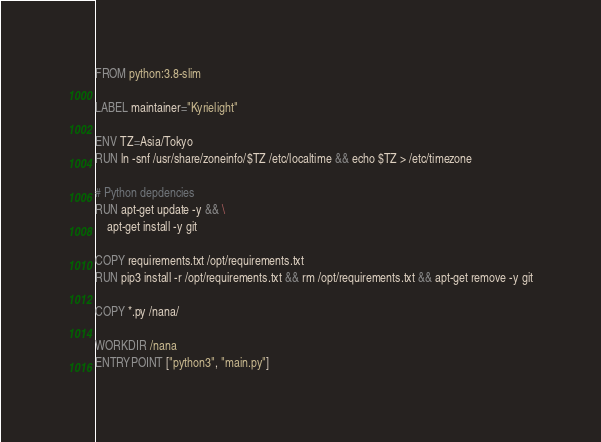Convert code to text. <code><loc_0><loc_0><loc_500><loc_500><_Dockerfile_>FROM python:3.8-slim

LABEL maintainer="Kyrielight"

ENV TZ=Asia/Tokyo
RUN ln -snf /usr/share/zoneinfo/$TZ /etc/localtime && echo $TZ > /etc/timezone

# Python depdencies
RUN apt-get update -y && \
    apt-get install -y git

COPY requirements.txt /opt/requirements.txt
RUN pip3 install -r /opt/requirements.txt && rm /opt/requirements.txt && apt-get remove -y git

COPY *.py /nana/

WORKDIR /nana
ENTRYPOINT ["python3", "main.py"]</code> 